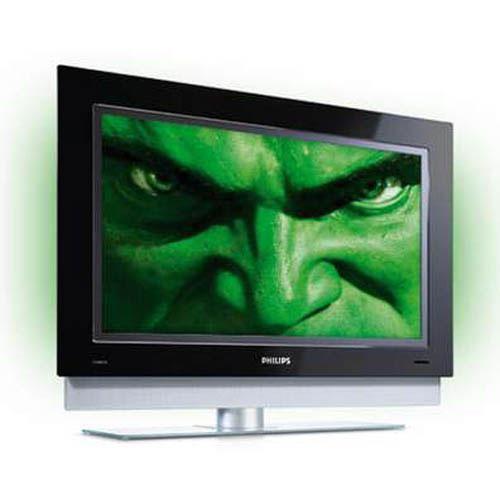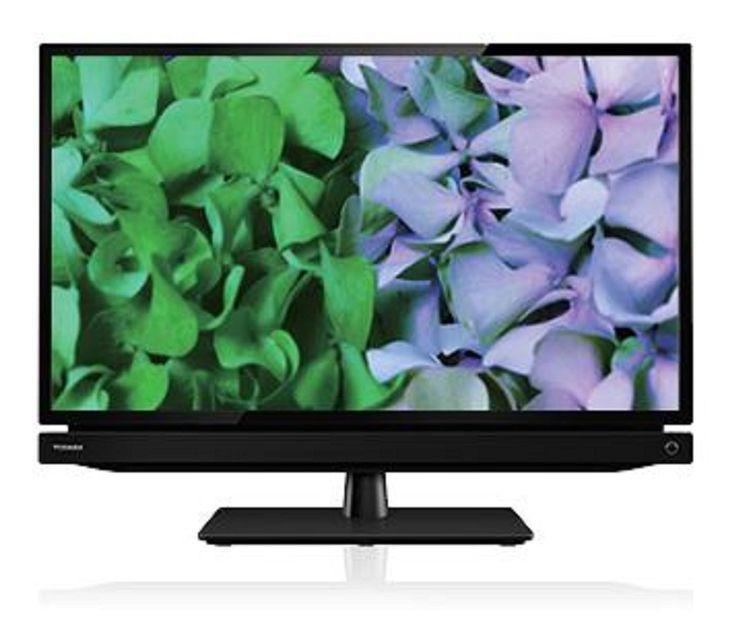The first image is the image on the left, the second image is the image on the right. Analyze the images presented: Is the assertion "The TV on the right is viewed head-on, and the TV on the left is displayed at an angle." valid? Answer yes or no. Yes. 